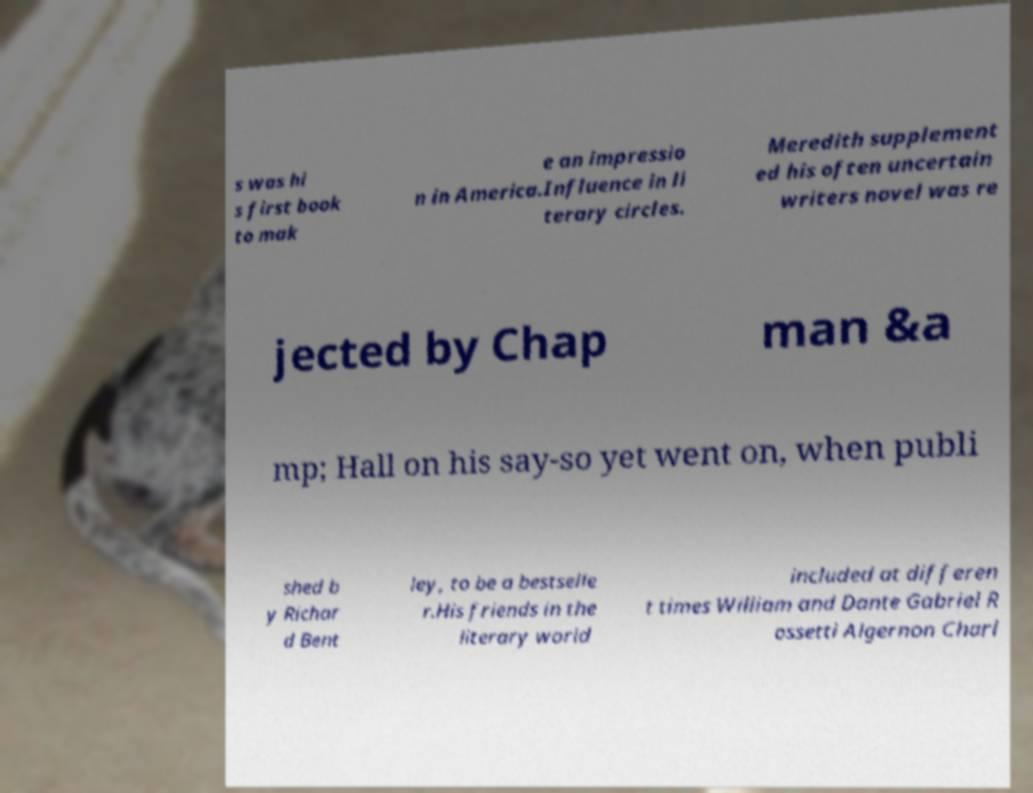Please read and relay the text visible in this image. What does it say? s was hi s first book to mak e an impressio n in America.Influence in li terary circles. Meredith supplement ed his often uncertain writers novel was re jected by Chap man &a mp; Hall on his say-so yet went on, when publi shed b y Richar d Bent ley, to be a bestselle r.His friends in the literary world included at differen t times William and Dante Gabriel R ossetti Algernon Charl 